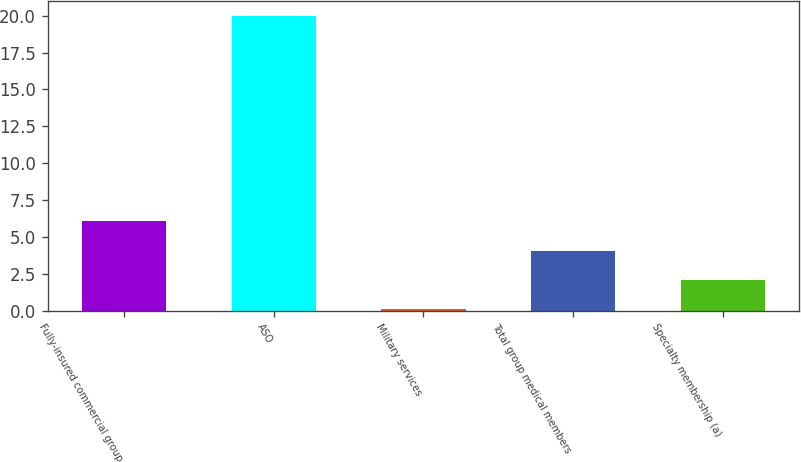Convert chart to OTSL. <chart><loc_0><loc_0><loc_500><loc_500><bar_chart><fcel>Fully-insured commercial group<fcel>ASO<fcel>Military services<fcel>Total group medical members<fcel>Specialty membership (a)<nl><fcel>6.07<fcel>20<fcel>0.1<fcel>4.08<fcel>2.09<nl></chart> 